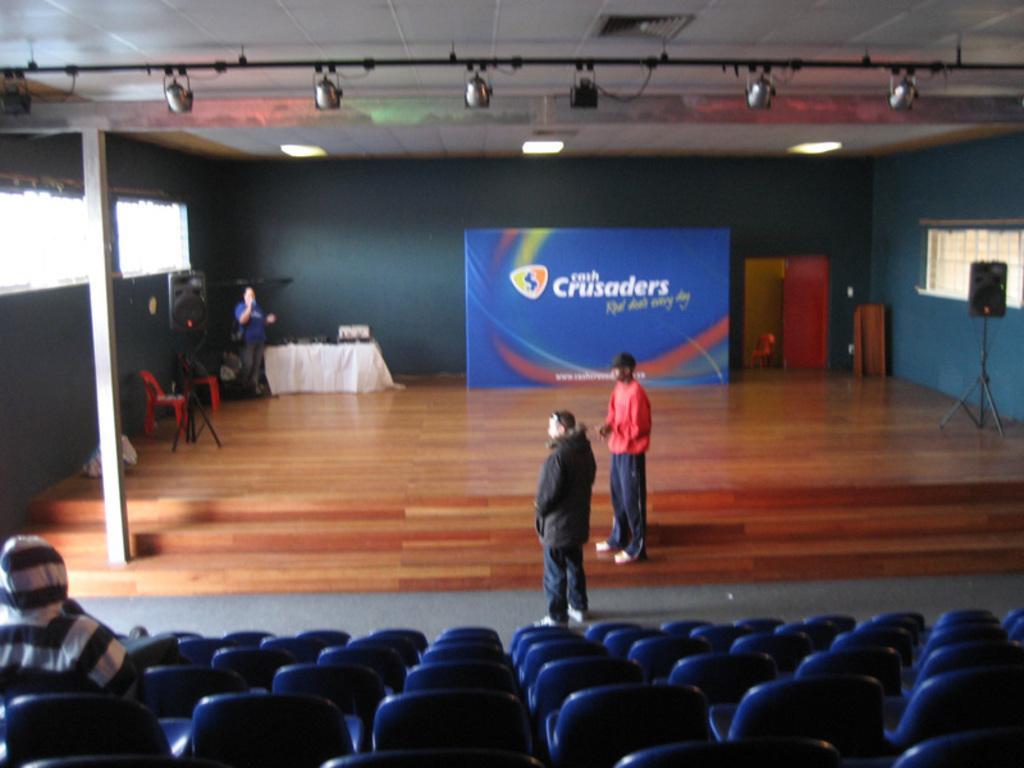Can you describe this image briefly? In this image in the center there are two persons standing, and at the bottom there are some chairs. On the chairs there is one person sitting, and on the left side of the image there is one person standing and some chairs and table and some objects and pillar. On the right side there is one speaker, and in the center there is a board and some doors. At the top there is ceiling and some lights, wire and pole. 